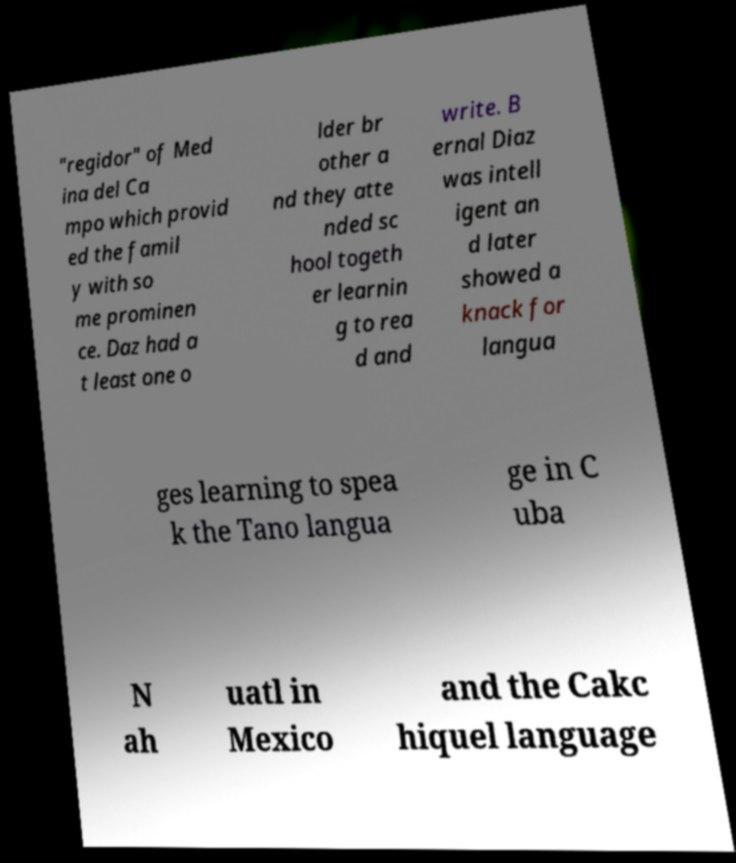Could you extract and type out the text from this image? "regidor" of Med ina del Ca mpo which provid ed the famil y with so me prominen ce. Daz had a t least one o lder br other a nd they atte nded sc hool togeth er learnin g to rea d and write. B ernal Diaz was intell igent an d later showed a knack for langua ges learning to spea k the Tano langua ge in C uba N ah uatl in Mexico and the Cakc hiquel language 